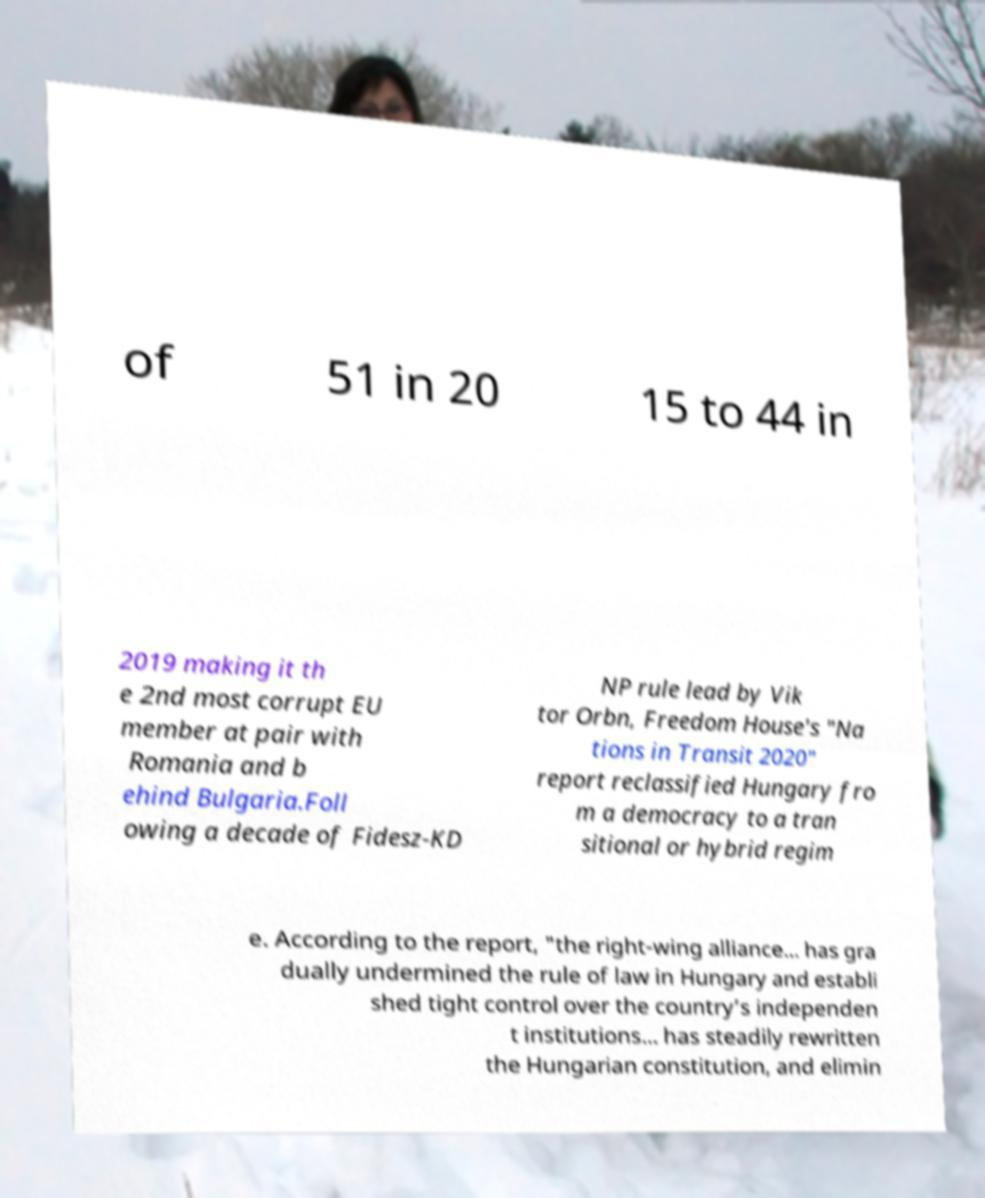What messages or text are displayed in this image? I need them in a readable, typed format. of 51 in 20 15 to 44 in 2019 making it th e 2nd most corrupt EU member at pair with Romania and b ehind Bulgaria.Foll owing a decade of Fidesz-KD NP rule lead by Vik tor Orbn, Freedom House's "Na tions in Transit 2020" report reclassified Hungary fro m a democracy to a tran sitional or hybrid regim e. According to the report, "the right-wing alliance... has gra dually undermined the rule of law in Hungary and establi shed tight control over the country’s independen t institutions... has steadily rewritten the Hungarian constitution, and elimin 